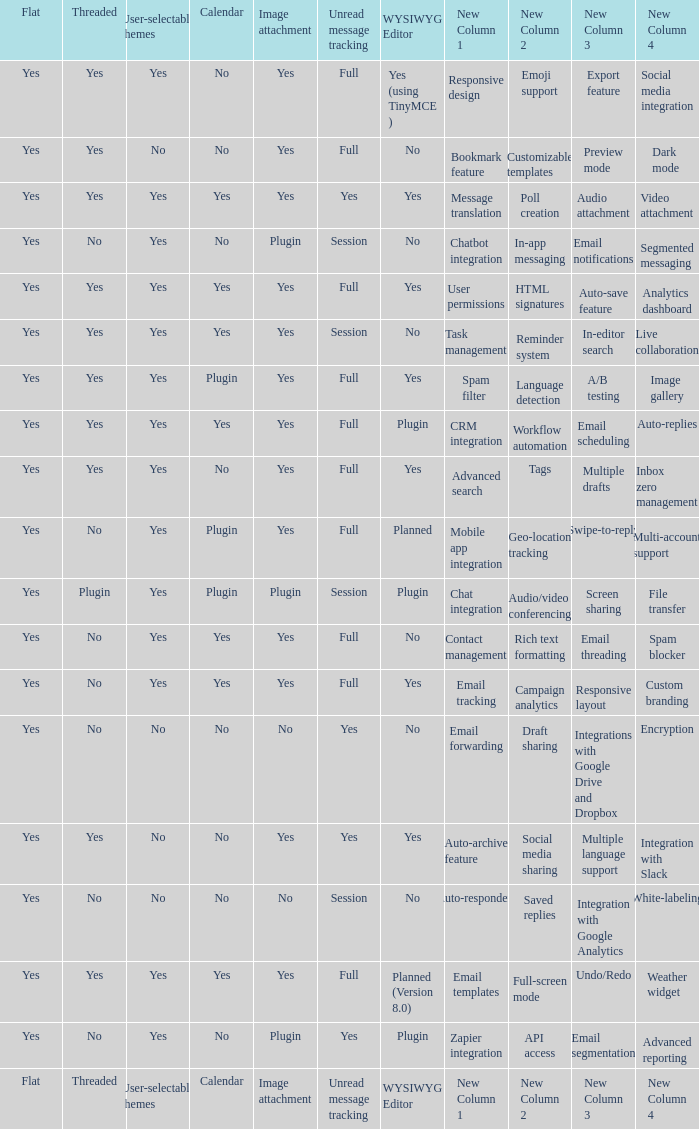Which Calendar has a User-selectable themes of user-selectable themes? Calendar. I'm looking to parse the entire table for insights. Could you assist me with that? {'header': ['Flat', 'Threaded', 'User-selectable themes', 'Calendar', 'Image attachment', 'Unread message tracking', 'WYSIWYG Editor', 'New Column 1', 'New Column 2', 'New Column 3', 'New Column 4'], 'rows': [['Yes', 'Yes', 'Yes', 'No', 'Yes', 'Full', 'Yes (using TinyMCE )', 'Responsive design', 'Emoji support', 'Export feature', 'Social media integration'], ['Yes', 'Yes', 'No', 'No', 'Yes', 'Full', 'No', 'Bookmark feature', 'Customizable templates', 'Preview mode', 'Dark mode '], ['Yes', 'Yes', 'Yes', 'Yes', 'Yes', 'Yes', 'Yes', 'Message translation', 'Poll creation', 'Audio attachment', 'Video attachment '], ['Yes', 'No', 'Yes', 'No', 'Plugin', 'Session', 'No', 'Chatbot integration', 'In-app messaging', 'Email notifications', 'Segmented messaging'], ['Yes', 'Yes', 'Yes', 'Yes', 'Yes', 'Full', 'Yes', 'User permissions', 'HTML signatures', 'Auto-save feature', 'Analytics dashboard'], ['Yes', 'Yes', 'Yes', 'Yes', 'Yes', 'Session', 'No', 'Task management', 'Reminder system', 'In-editor search', 'Live collaboration'], ['Yes', 'Yes', 'Yes', 'Plugin', 'Yes', 'Full', 'Yes', 'Spam filter', 'Language detection', 'A/B testing', 'Image gallery'], ['Yes', 'Yes', 'Yes', 'Yes', 'Yes', 'Full', 'Plugin', 'CRM integration', 'Workflow automation', 'Email scheduling', 'Auto-replies'], ['Yes', 'Yes', 'Yes', 'No', 'Yes', 'Full', 'Yes', 'Advanced search', 'Tags', 'Multiple drafts', 'Inbox zero management'], ['Yes', 'No', 'Yes', 'Plugin', 'Yes', 'Full', 'Planned', 'Mobile app integration', 'Geo-location tracking', 'Swipe-to-reply', 'Multi-account support '], ['Yes', 'Plugin', 'Yes', 'Plugin', 'Plugin', 'Session', 'Plugin', 'Chat integration', 'Audio/video conferencing', 'Screen sharing', 'File transfer'], ['Yes', 'No', 'Yes', 'Yes', 'Yes', 'Full', 'No', 'Contact management', 'Rich text formatting', 'Email threading', 'Spam blocker'], ['Yes', 'No', 'Yes', 'Yes', 'Yes', 'Full', 'Yes', 'Email tracking', 'Campaign analytics', 'Responsive layout', 'Custom branding'], ['Yes', 'No', 'No', 'No', 'No', 'Yes', 'No', 'Email forwarding', 'Draft sharing', 'Integrations with Google Drive and Dropbox', 'Encryption'], ['Yes', 'Yes', 'No', 'No', 'Yes', 'Yes', 'Yes', 'Auto-archive feature', 'Social media sharing', 'Multiple language support', 'Integration with Slack'], ['Yes', 'No', 'No', 'No', 'No', 'Session', 'No', 'Auto-responders', 'Saved replies', 'Integration with Google Analytics', 'White-labeling'], ['Yes', 'Yes', 'Yes', 'Yes', 'Yes', 'Full', 'Planned (Version 8.0)', 'Email templates', 'Full-screen mode', 'Undo/Redo', 'Weather widget'], ['Yes', 'No', 'Yes', 'No', 'Plugin', 'Yes', 'Plugin', 'Zapier integration', 'API access', 'Email segmentation', 'Advanced reporting '], ['Flat', 'Threaded', 'User-selectable themes', 'Calendar', 'Image attachment', 'Unread message tracking', 'WYSIWYG Editor', 'New Column 1', 'New Column 2', 'New Column 3', 'New Column 4']]} 